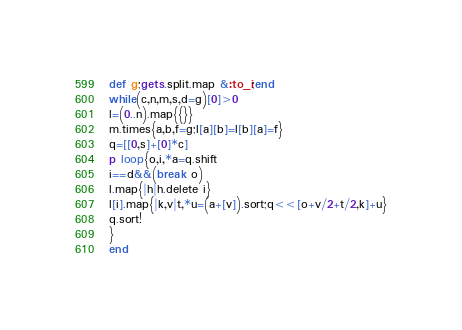<code> <loc_0><loc_0><loc_500><loc_500><_Ruby_>def g;gets.split.map &:to_i;end
while(c,n,m,s,d=g)[0]>0
l=(0..n).map{{}}
m.times{a,b,f=g;l[a][b]=l[b][a]=f}
q=[[0,s]+[0]*c]
p loop{o,i,*a=q.shift
i==d&&(break o)
l.map{|h|h.delete i}
l[i].map{|k,v|t,*u=(a+[v]).sort;q<<[o+v/2+t/2,k]+u}
q.sort!
}
end</code> 